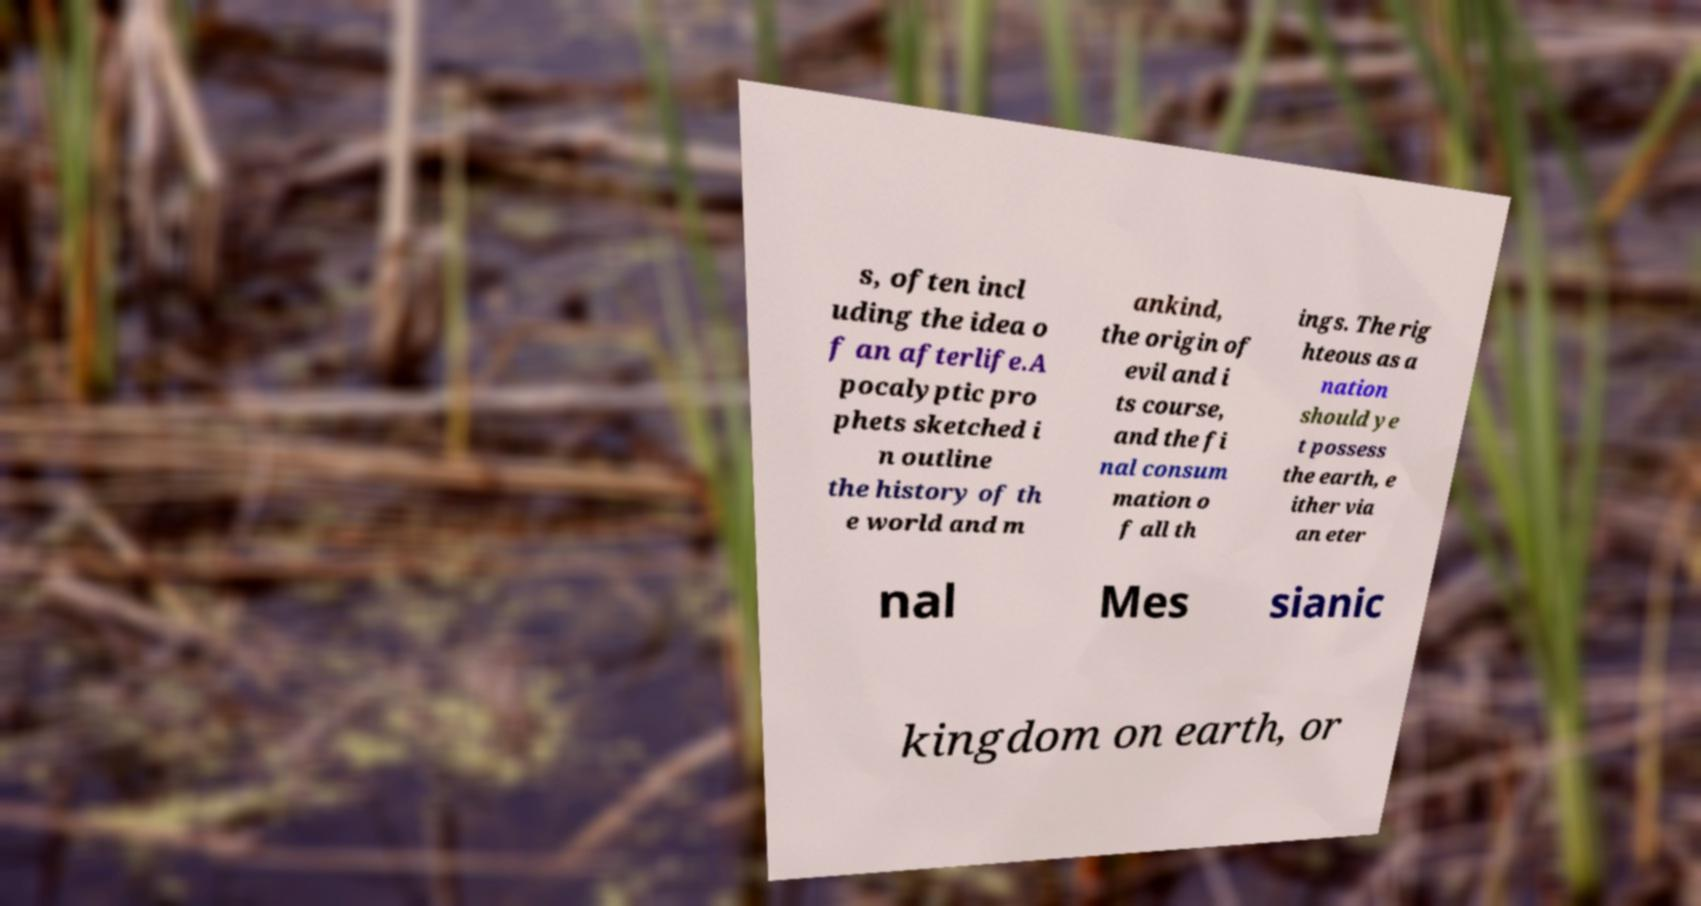Can you accurately transcribe the text from the provided image for me? s, often incl uding the idea o f an afterlife.A pocalyptic pro phets sketched i n outline the history of th e world and m ankind, the origin of evil and i ts course, and the fi nal consum mation o f all th ings. The rig hteous as a nation should ye t possess the earth, e ither via an eter nal Mes sianic kingdom on earth, or 